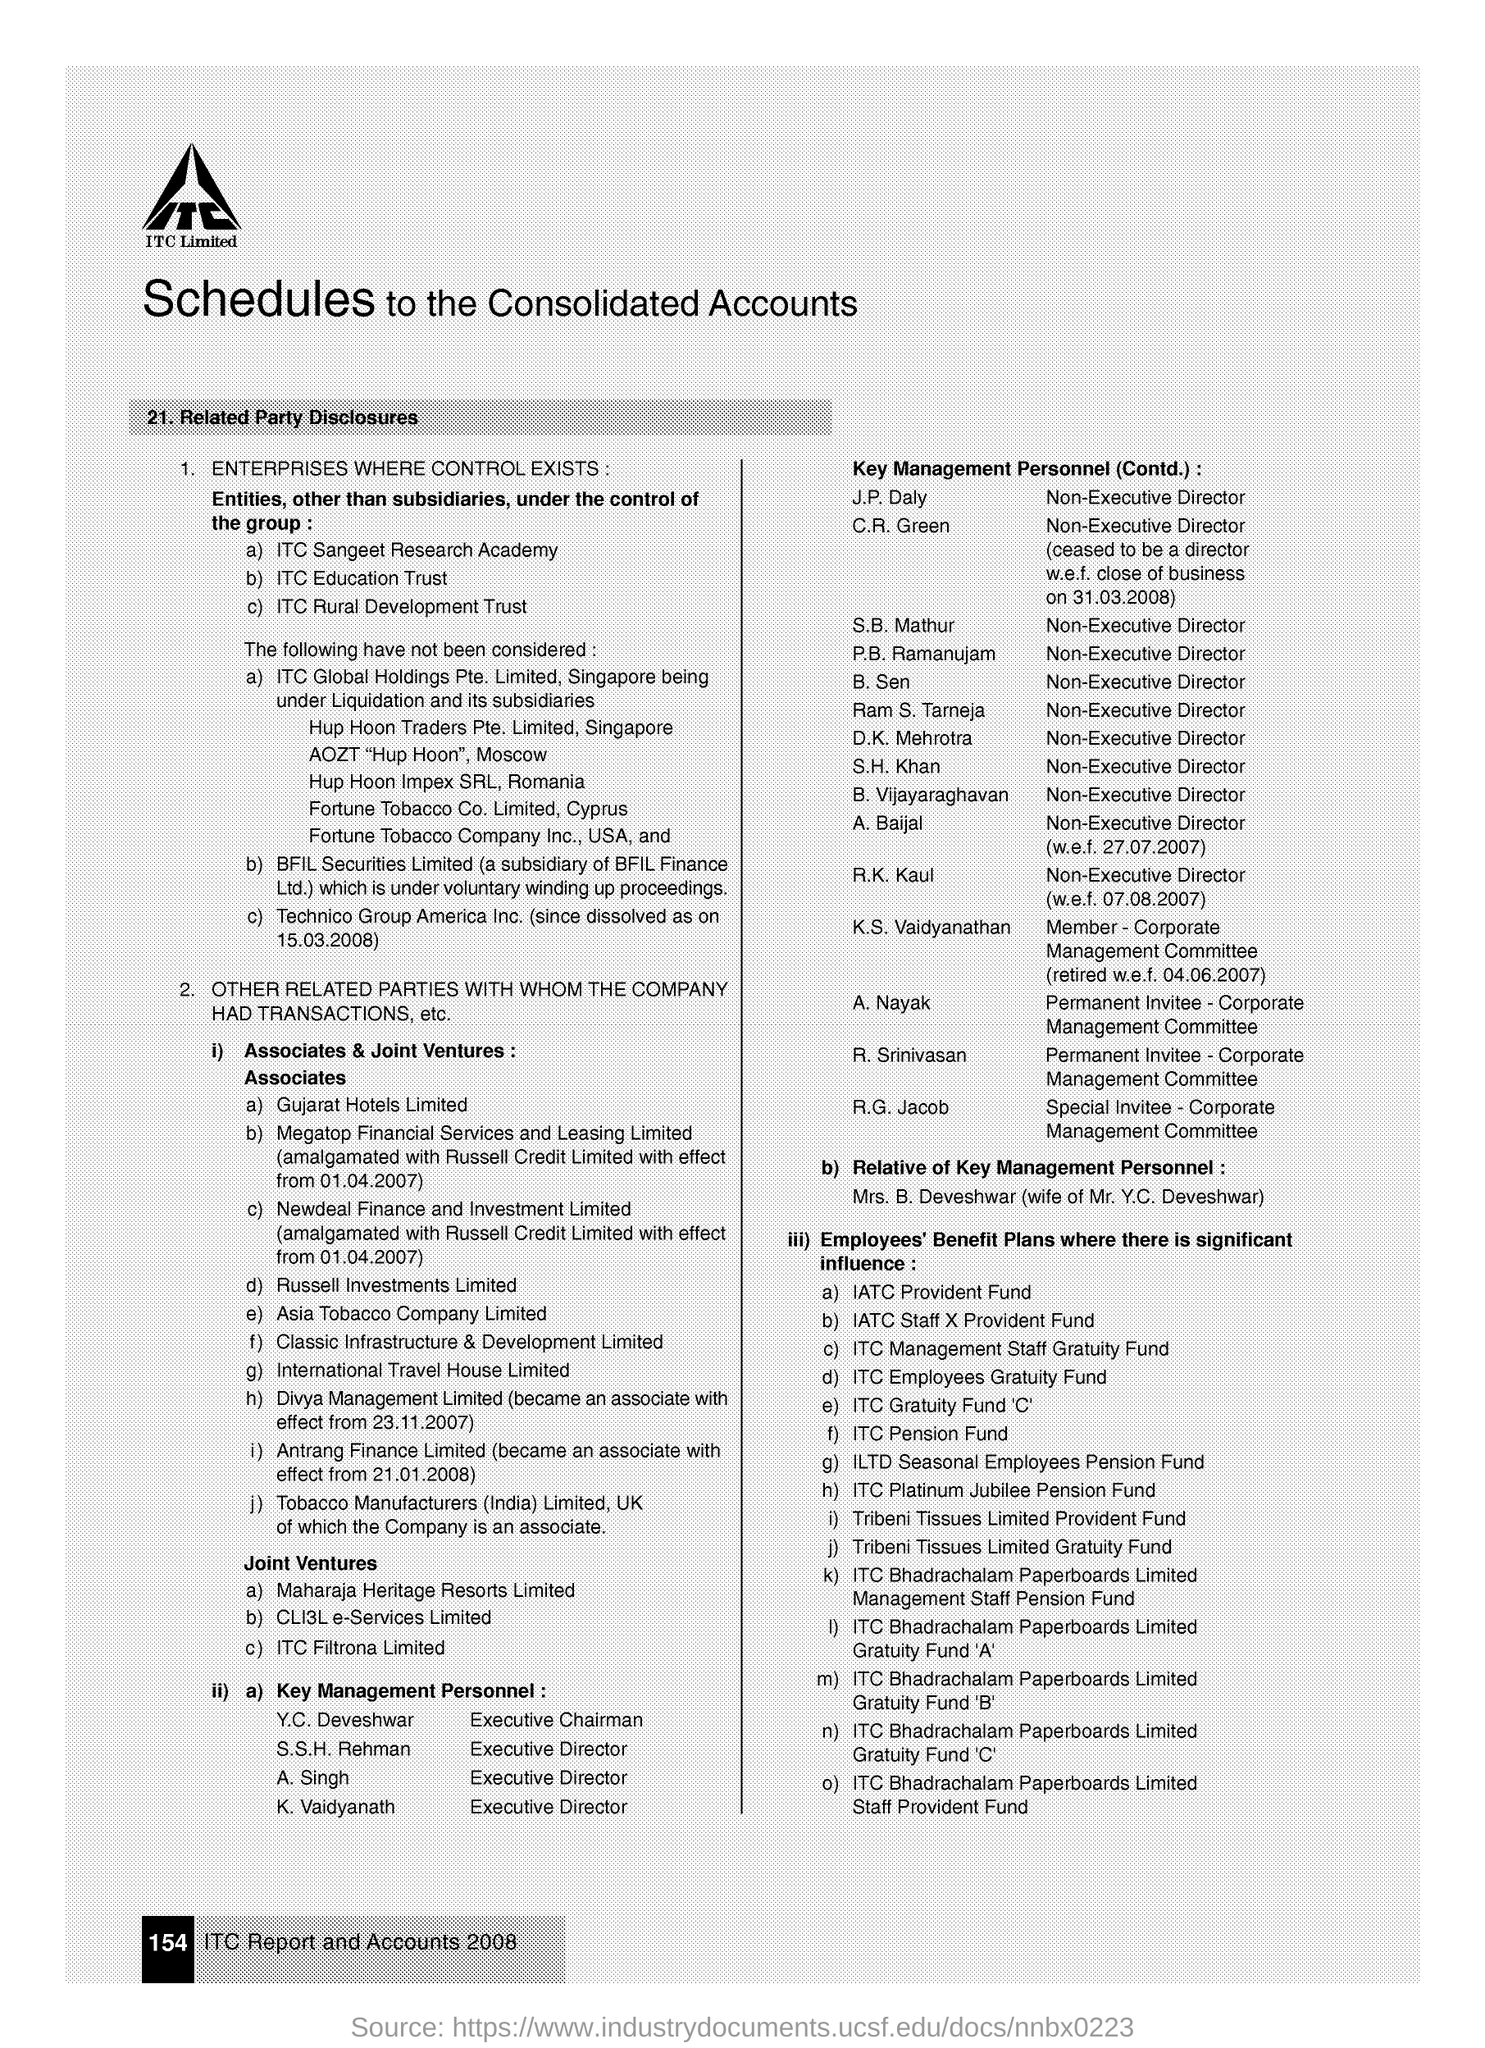What is the main title of this document?
Give a very brief answer. Schedules to the Consolidated Accounts. What is the designation of S. B. Mathur?
Ensure brevity in your answer.  Non-Executive Director. Who is the Special Invitee- Corporate Management Committee?
Your response must be concise. R.G. Jacob. What is the page no mentioned in this document?
Offer a very short reply. 154. Who is the wife of  Mr. Y.C. Deveshwar?
Offer a very short reply. Mrs. B. Deveshwar. 